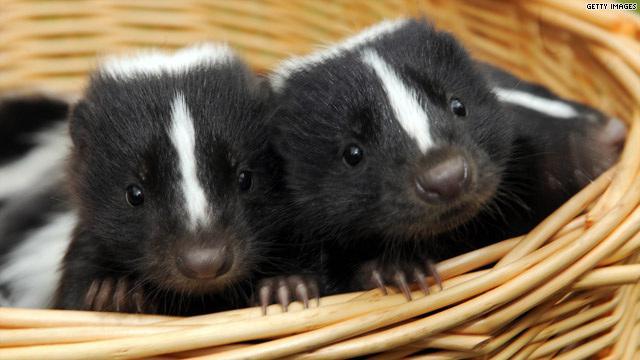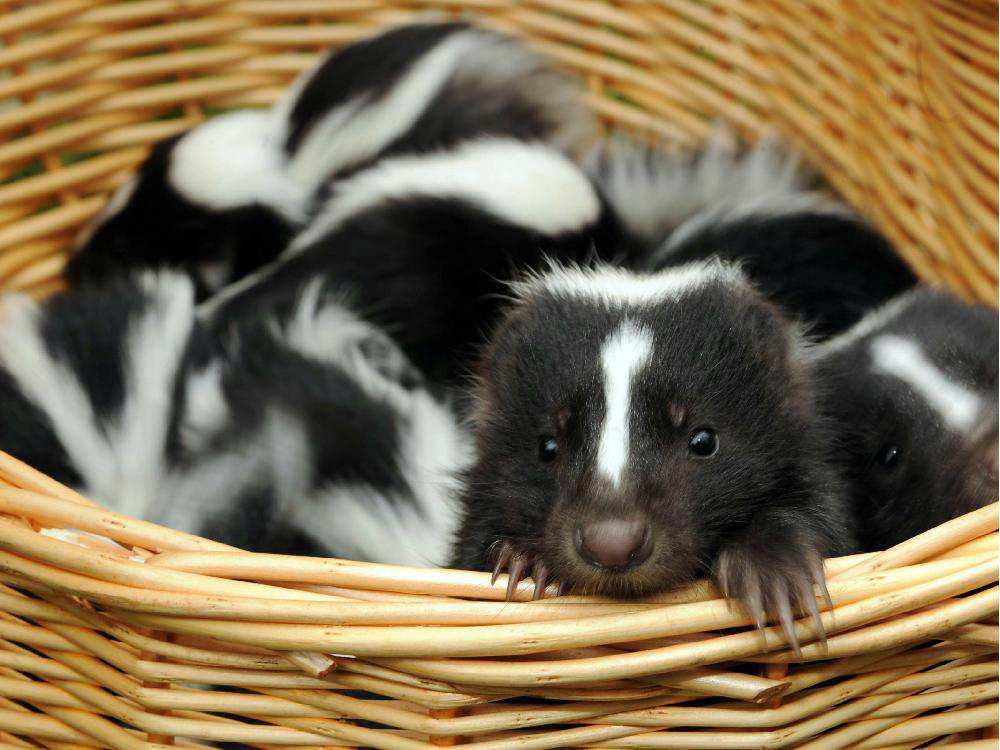The first image is the image on the left, the second image is the image on the right. Evaluate the accuracy of this statement regarding the images: "The left image contains at least one skunk in basket.". Is it true? Answer yes or no. Yes. The first image is the image on the left, the second image is the image on the right. Evaluate the accuracy of this statement regarding the images: "At least one camera-gazing skunk has both its front paws on the edge of a basket.". Is it true? Answer yes or no. Yes. 